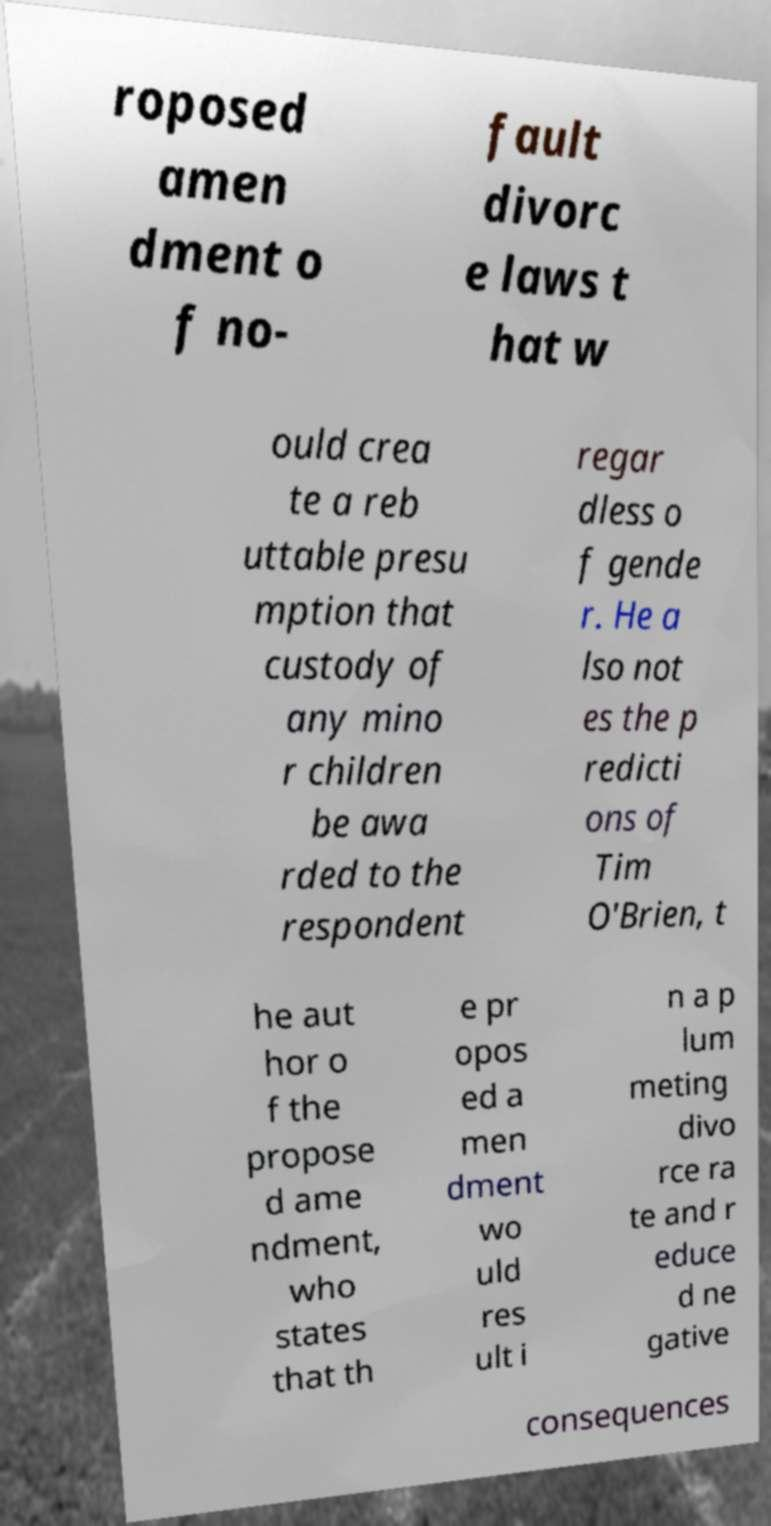I need the written content from this picture converted into text. Can you do that? roposed amen dment o f no- fault divorc e laws t hat w ould crea te a reb uttable presu mption that custody of any mino r children be awa rded to the respondent regar dless o f gende r. He a lso not es the p redicti ons of Tim O'Brien, t he aut hor o f the propose d ame ndment, who states that th e pr opos ed a men dment wo uld res ult i n a p lum meting divo rce ra te and r educe d ne gative consequences 